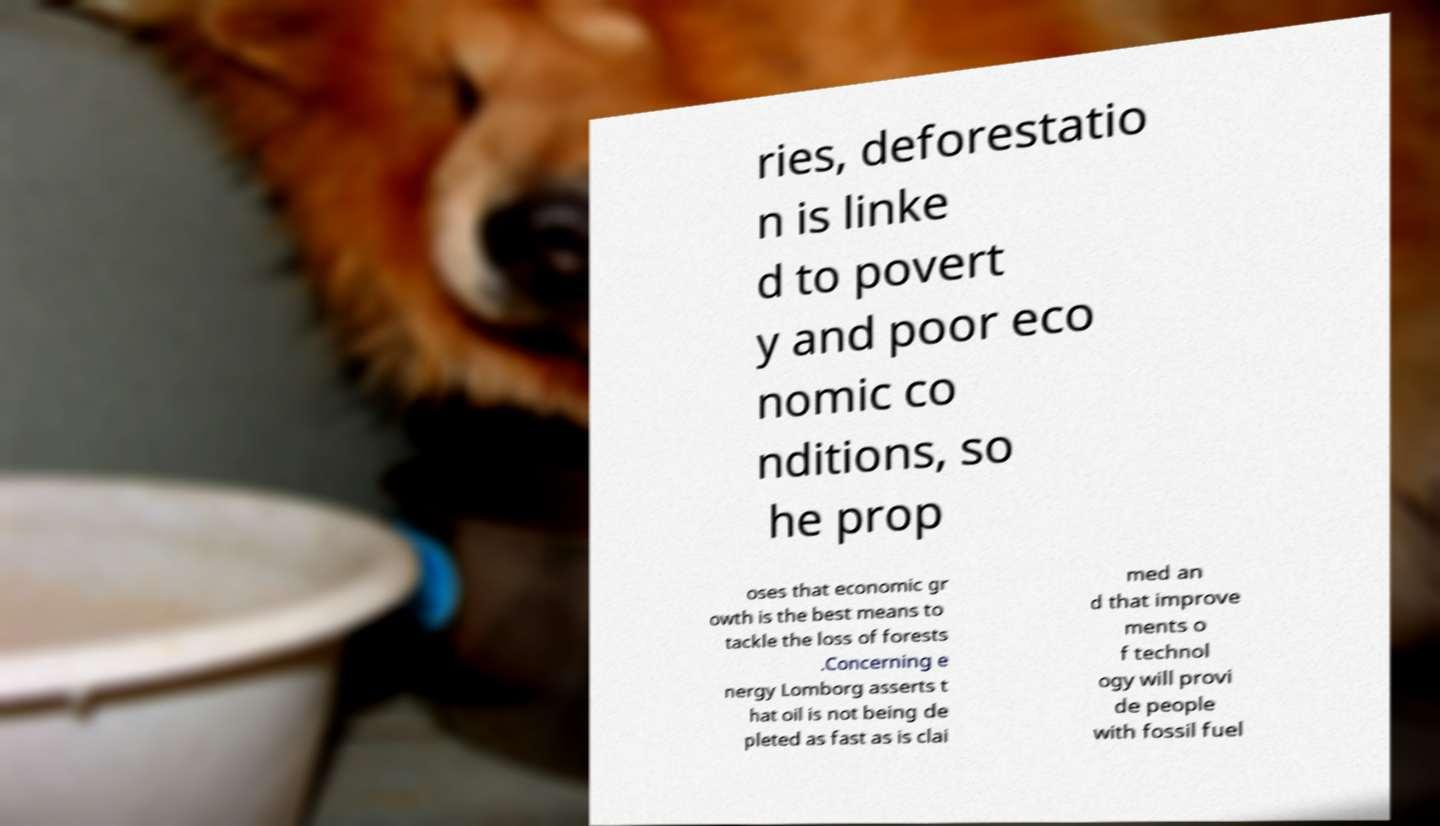Can you accurately transcribe the text from the provided image for me? ries, deforestatio n is linke d to povert y and poor eco nomic co nditions, so he prop oses that economic gr owth is the best means to tackle the loss of forests .Concerning e nergy Lomborg asserts t hat oil is not being de pleted as fast as is clai med an d that improve ments o f technol ogy will provi de people with fossil fuel 